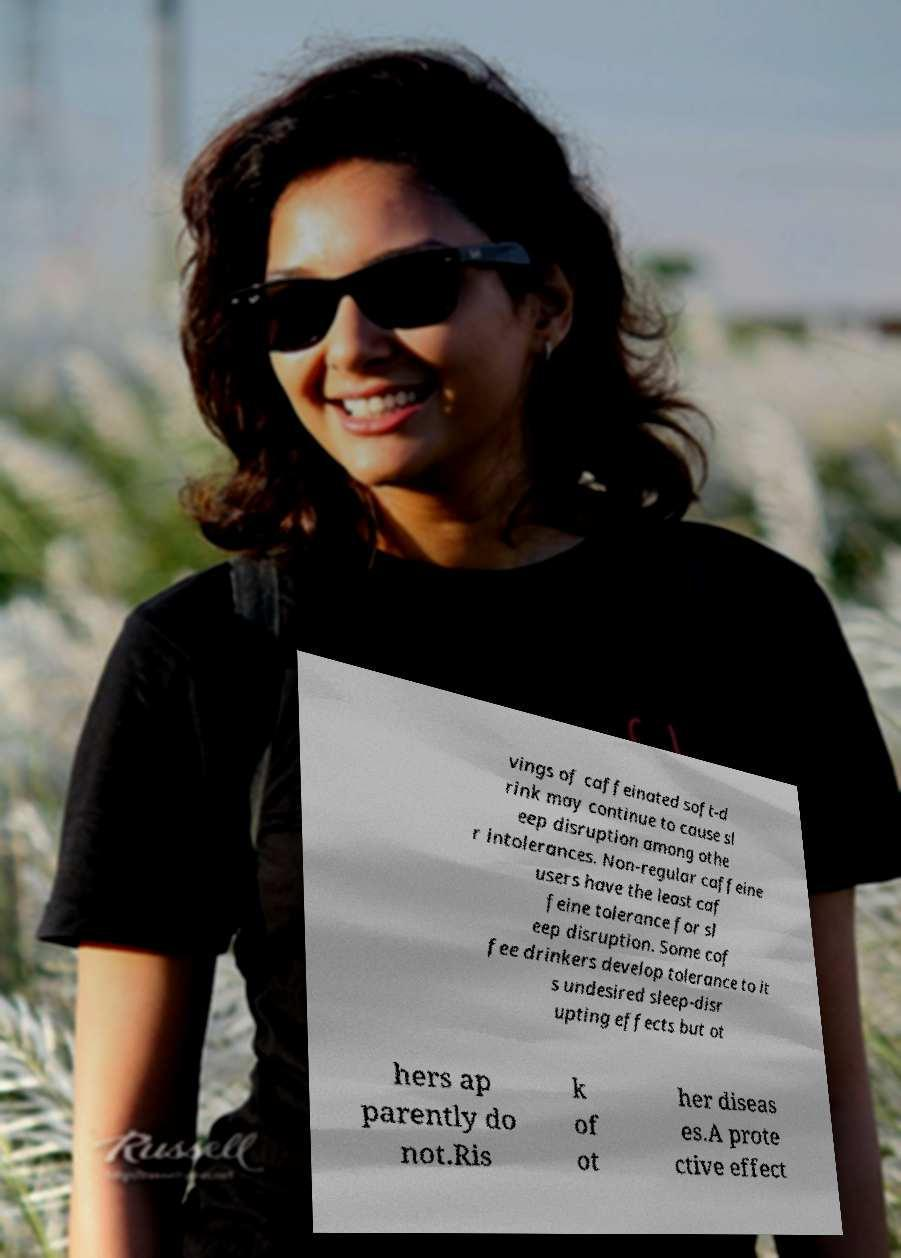Could you extract and type out the text from this image? vings of caffeinated soft-d rink may continue to cause sl eep disruption among othe r intolerances. Non-regular caffeine users have the least caf feine tolerance for sl eep disruption. Some cof fee drinkers develop tolerance to it s undesired sleep-disr upting effects but ot hers ap parently do not.Ris k of ot her diseas es.A prote ctive effect 